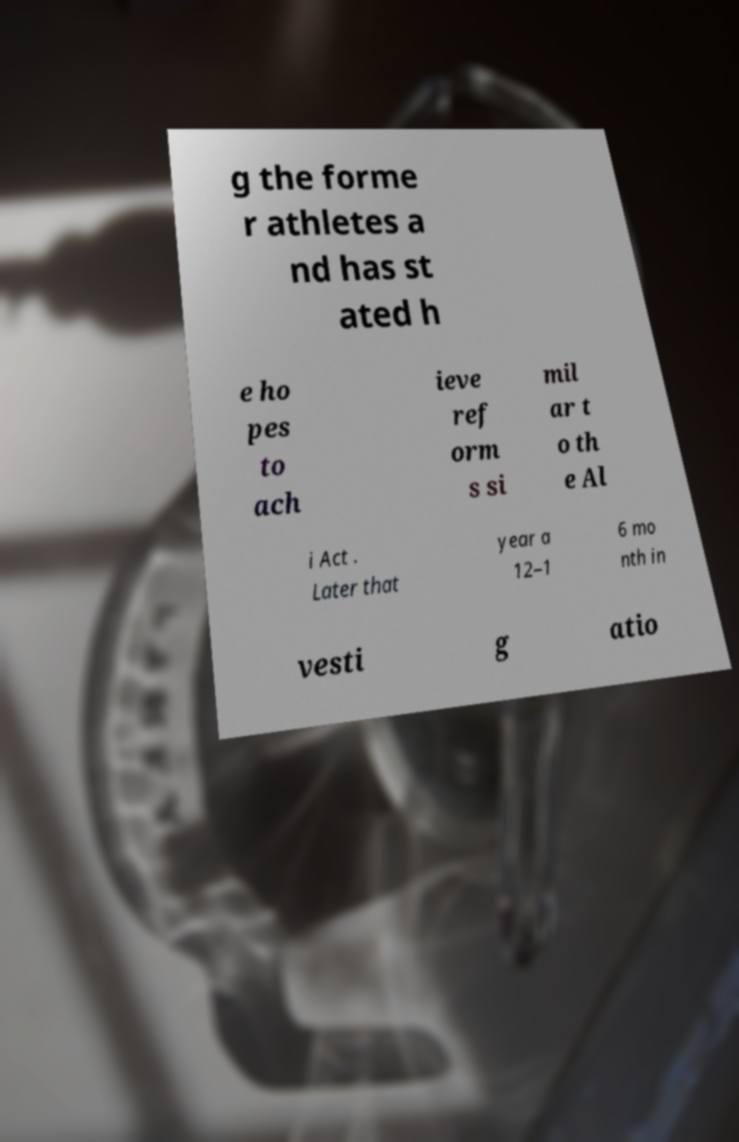I need the written content from this picture converted into text. Can you do that? g the forme r athletes a nd has st ated h e ho pes to ach ieve ref orm s si mil ar t o th e Al i Act . Later that year a 12–1 6 mo nth in vesti g atio 